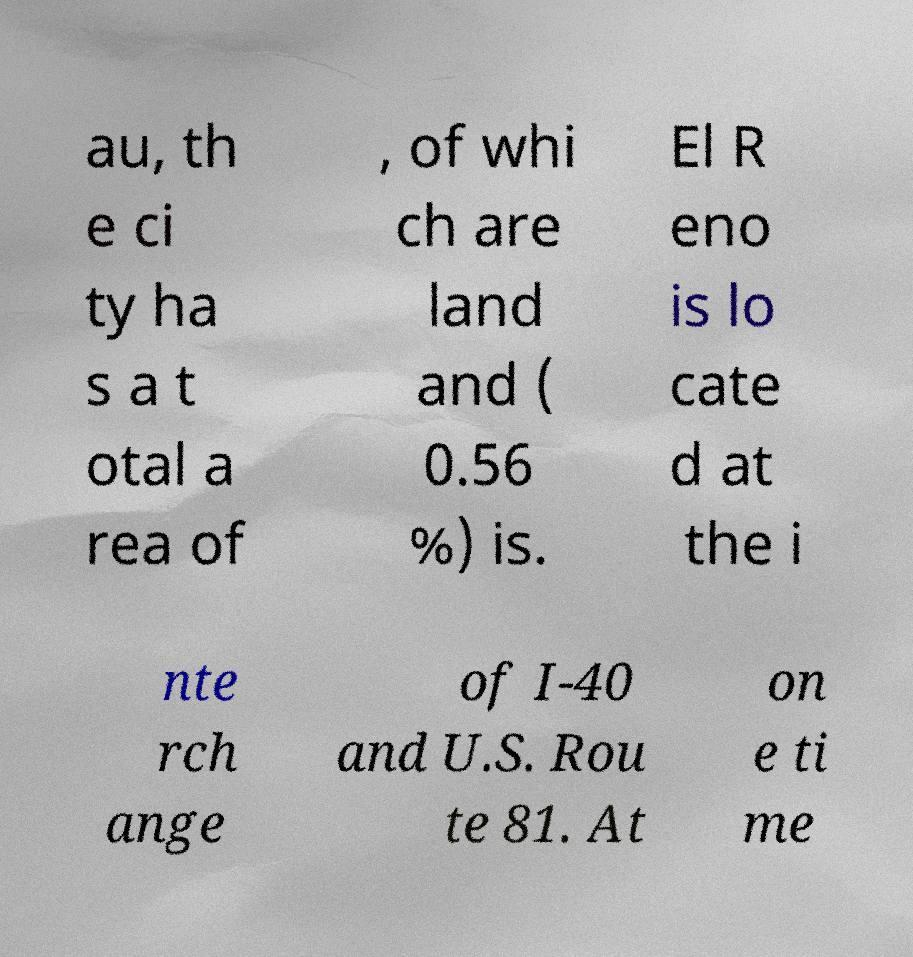There's text embedded in this image that I need extracted. Can you transcribe it verbatim? au, th e ci ty ha s a t otal a rea of , of whi ch are land and ( 0.56 %) is. El R eno is lo cate d at the i nte rch ange of I-40 and U.S. Rou te 81. At on e ti me 